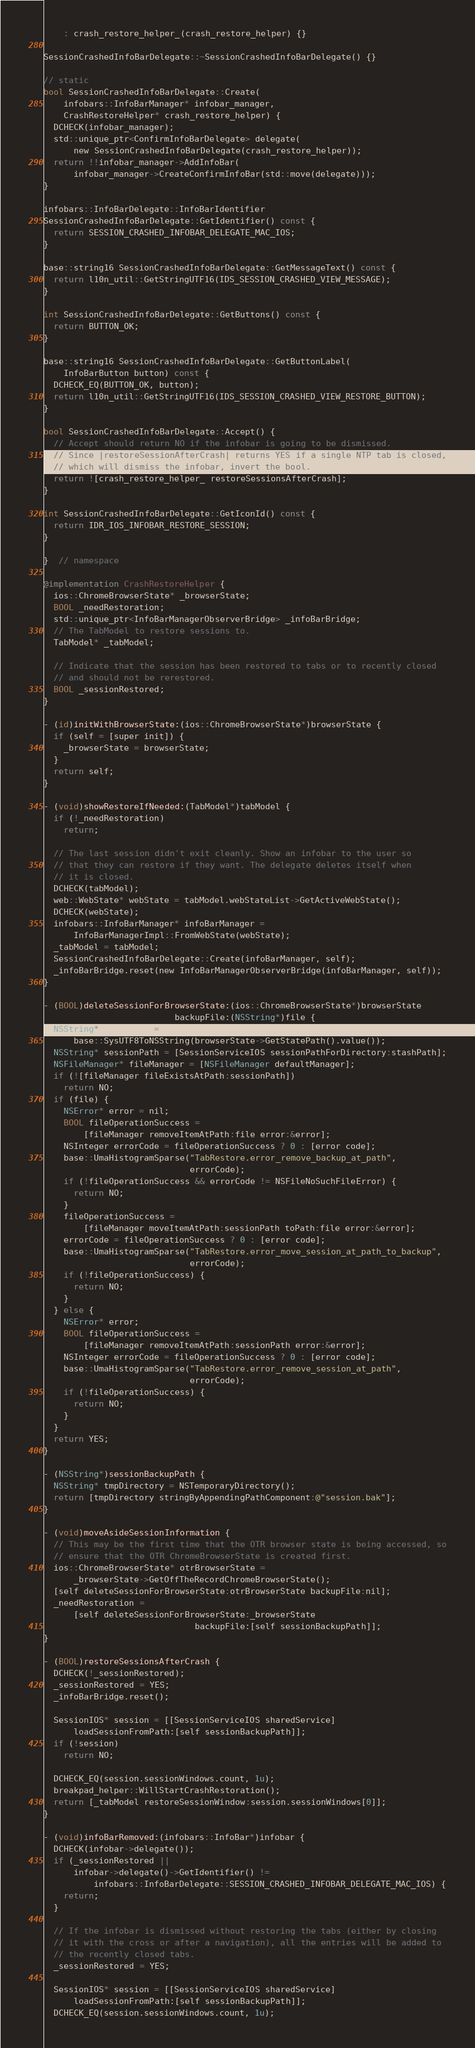Convert code to text. <code><loc_0><loc_0><loc_500><loc_500><_ObjectiveC_>    : crash_restore_helper_(crash_restore_helper) {}

SessionCrashedInfoBarDelegate::~SessionCrashedInfoBarDelegate() {}

// static
bool SessionCrashedInfoBarDelegate::Create(
    infobars::InfoBarManager* infobar_manager,
    CrashRestoreHelper* crash_restore_helper) {
  DCHECK(infobar_manager);
  std::unique_ptr<ConfirmInfoBarDelegate> delegate(
      new SessionCrashedInfoBarDelegate(crash_restore_helper));
  return !!infobar_manager->AddInfoBar(
      infobar_manager->CreateConfirmInfoBar(std::move(delegate)));
}

infobars::InfoBarDelegate::InfoBarIdentifier
SessionCrashedInfoBarDelegate::GetIdentifier() const {
  return SESSION_CRASHED_INFOBAR_DELEGATE_MAC_IOS;
}

base::string16 SessionCrashedInfoBarDelegate::GetMessageText() const {
  return l10n_util::GetStringUTF16(IDS_SESSION_CRASHED_VIEW_MESSAGE);
}

int SessionCrashedInfoBarDelegate::GetButtons() const {
  return BUTTON_OK;
}

base::string16 SessionCrashedInfoBarDelegate::GetButtonLabel(
    InfoBarButton button) const {
  DCHECK_EQ(BUTTON_OK, button);
  return l10n_util::GetStringUTF16(IDS_SESSION_CRASHED_VIEW_RESTORE_BUTTON);
}

bool SessionCrashedInfoBarDelegate::Accept() {
  // Accept should return NO if the infobar is going to be dismissed.
  // Since |restoreSessionAfterCrash| returns YES if a single NTP tab is closed,
  // which will dismiss the infobar, invert the bool.
  return ![crash_restore_helper_ restoreSessionsAfterCrash];
}

int SessionCrashedInfoBarDelegate::GetIconId() const {
  return IDR_IOS_INFOBAR_RESTORE_SESSION;
}

}  // namespace

@implementation CrashRestoreHelper {
  ios::ChromeBrowserState* _browserState;
  BOOL _needRestoration;
  std::unique_ptr<InfoBarManagerObserverBridge> _infoBarBridge;
  // The TabModel to restore sessions to.
  TabModel* _tabModel;

  // Indicate that the session has been restored to tabs or to recently closed
  // and should not be rerestored.
  BOOL _sessionRestored;
}

- (id)initWithBrowserState:(ios::ChromeBrowserState*)browserState {
  if (self = [super init]) {
    _browserState = browserState;
  }
  return self;
}

- (void)showRestoreIfNeeded:(TabModel*)tabModel {
  if (!_needRestoration)
    return;

  // The last session didn't exit cleanly. Show an infobar to the user so
  // that they can restore if they want. The delegate deletes itself when
  // it is closed.
  DCHECK(tabModel);
  web::WebState* webState = tabModel.webStateList->GetActiveWebState();
  DCHECK(webState);
  infobars::InfoBarManager* infoBarManager =
      InfoBarManagerImpl::FromWebState(webState);
  _tabModel = tabModel;
  SessionCrashedInfoBarDelegate::Create(infoBarManager, self);
  _infoBarBridge.reset(new InfoBarManagerObserverBridge(infoBarManager, self));
}

- (BOOL)deleteSessionForBrowserState:(ios::ChromeBrowserState*)browserState
                          backupFile:(NSString*)file {
  NSString* stashPath =
      base::SysUTF8ToNSString(browserState->GetStatePath().value());
  NSString* sessionPath = [SessionServiceIOS sessionPathForDirectory:stashPath];
  NSFileManager* fileManager = [NSFileManager defaultManager];
  if (![fileManager fileExistsAtPath:sessionPath])
    return NO;
  if (file) {
    NSError* error = nil;
    BOOL fileOperationSuccess =
        [fileManager removeItemAtPath:file error:&error];
    NSInteger errorCode = fileOperationSuccess ? 0 : [error code];
    base::UmaHistogramSparse("TabRestore.error_remove_backup_at_path",
                             errorCode);
    if (!fileOperationSuccess && errorCode != NSFileNoSuchFileError) {
      return NO;
    }
    fileOperationSuccess =
        [fileManager moveItemAtPath:sessionPath toPath:file error:&error];
    errorCode = fileOperationSuccess ? 0 : [error code];
    base::UmaHistogramSparse("TabRestore.error_move_session_at_path_to_backup",
                             errorCode);
    if (!fileOperationSuccess) {
      return NO;
    }
  } else {
    NSError* error;
    BOOL fileOperationSuccess =
        [fileManager removeItemAtPath:sessionPath error:&error];
    NSInteger errorCode = fileOperationSuccess ? 0 : [error code];
    base::UmaHistogramSparse("TabRestore.error_remove_session_at_path",
                             errorCode);
    if (!fileOperationSuccess) {
      return NO;
    }
  }
  return YES;
}

- (NSString*)sessionBackupPath {
  NSString* tmpDirectory = NSTemporaryDirectory();
  return [tmpDirectory stringByAppendingPathComponent:@"session.bak"];
}

- (void)moveAsideSessionInformation {
  // This may be the first time that the OTR browser state is being accessed, so
  // ensure that the OTR ChromeBrowserState is created first.
  ios::ChromeBrowserState* otrBrowserState =
      _browserState->GetOffTheRecordChromeBrowserState();
  [self deleteSessionForBrowserState:otrBrowserState backupFile:nil];
  _needRestoration =
      [self deleteSessionForBrowserState:_browserState
                              backupFile:[self sessionBackupPath]];
}

- (BOOL)restoreSessionsAfterCrash {
  DCHECK(!_sessionRestored);
  _sessionRestored = YES;
  _infoBarBridge.reset();

  SessionIOS* session = [[SessionServiceIOS sharedService]
      loadSessionFromPath:[self sessionBackupPath]];
  if (!session)
    return NO;

  DCHECK_EQ(session.sessionWindows.count, 1u);
  breakpad_helper::WillStartCrashRestoration();
  return [_tabModel restoreSessionWindow:session.sessionWindows[0]];
}

- (void)infoBarRemoved:(infobars::InfoBar*)infobar {
  DCHECK(infobar->delegate());
  if (_sessionRestored ||
      infobar->delegate()->GetIdentifier() !=
          infobars::InfoBarDelegate::SESSION_CRASHED_INFOBAR_DELEGATE_MAC_IOS) {
    return;
  }

  // If the infobar is dismissed without restoring the tabs (either by closing
  // it with the cross or after a navigation), all the entries will be added to
  // the recently closed tabs.
  _sessionRestored = YES;

  SessionIOS* session = [[SessionServiceIOS sharedService]
      loadSessionFromPath:[self sessionBackupPath]];
  DCHECK_EQ(session.sessionWindows.count, 1u);
</code> 